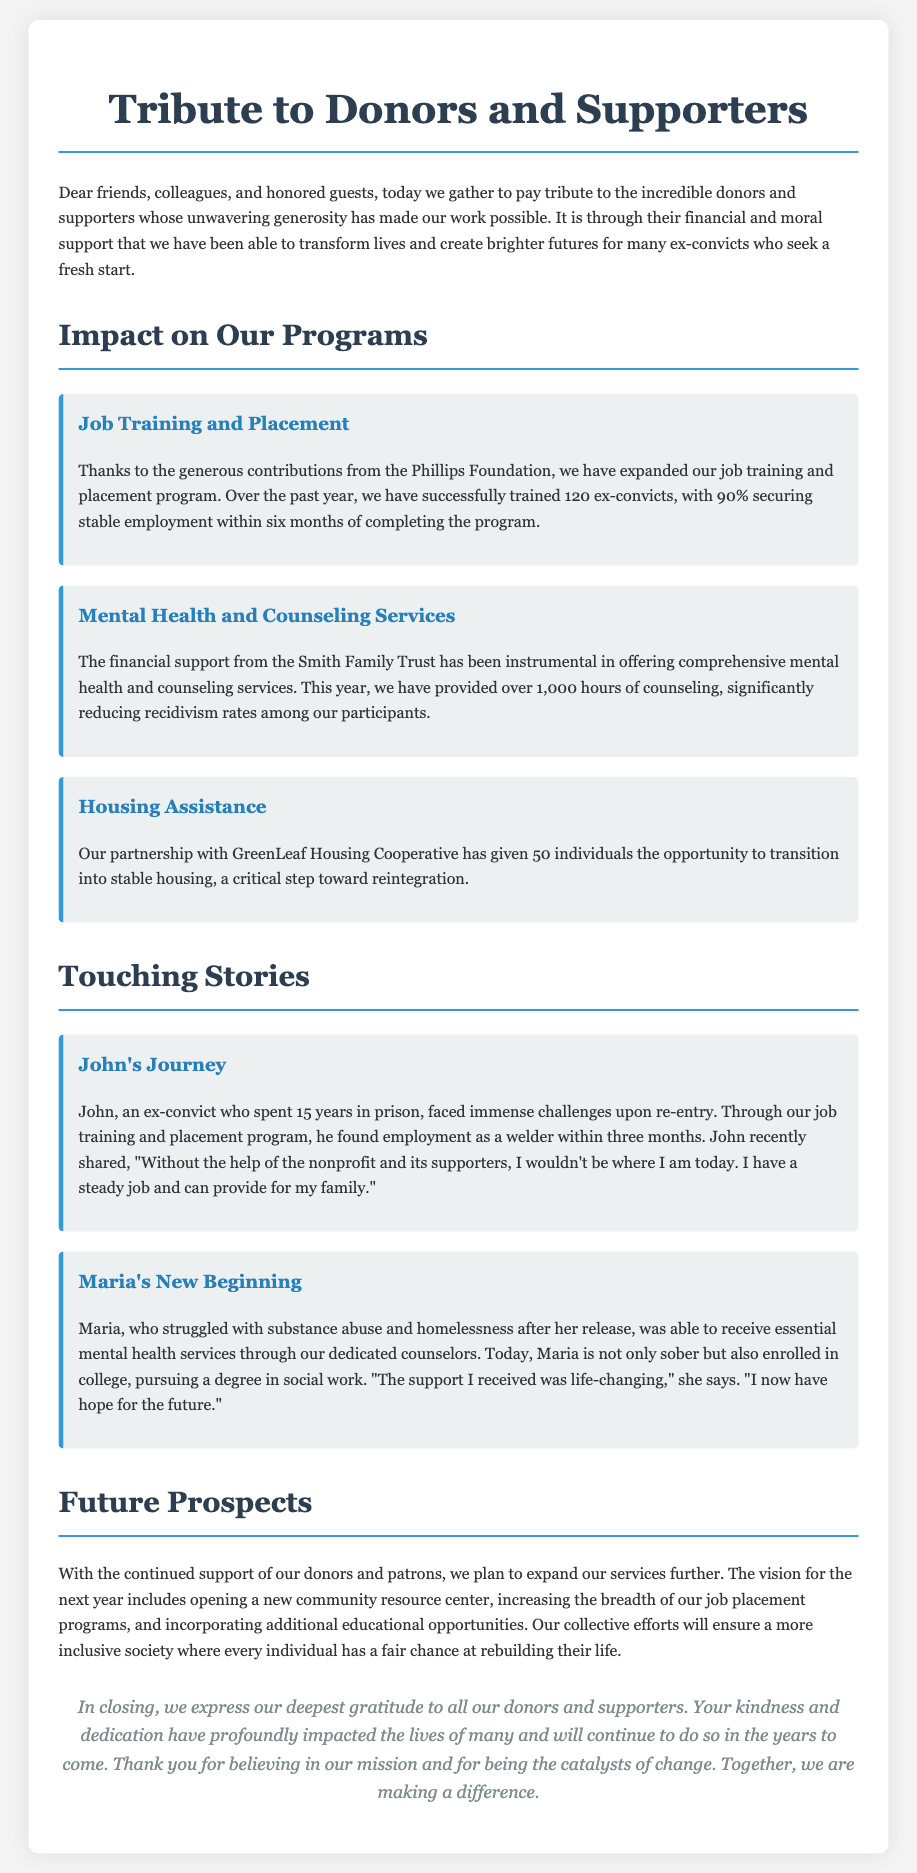What is the title of the document? The title of the document is found at the top of the rendered eulogy.
Answer: Tribute to Donors and Supporters How many ex-convicts were trained in the job training program? The document states the number of ex-convicts trained in the specific program mentioned.
Answer: 120 What percentage of those trained secured employment? The percentage of ex-convicts who found employment is indicated in the performance of the job training program.
Answer: 90% Which foundation contributed to the job training program? The specific name of the foundation that supported the job training and placement program is revealed in the document.
Answer: Phillips Foundation How many hours of counseling were provided? The document specifies the total counseling hours offered as part of the mental health services program.
Answer: 1,000 hours What was John's occupation after training? The occupation that John secured after completing the job training program is detailed in the touching story section.
Answer: Welder Which service significantly helped Maria? The service that transformed Maria's life is mentioned within her personal story in the document.
Answer: Mental health services What is the vision for the next year? The document outlines the planned expansion of services and initiatives for the upcoming year.
Answer: Opening a new community resource center Who do we express gratitude to at the end? The individuals recognized for their support are mentioned in the closing of the eulogy.
Answer: Donors and supporters 